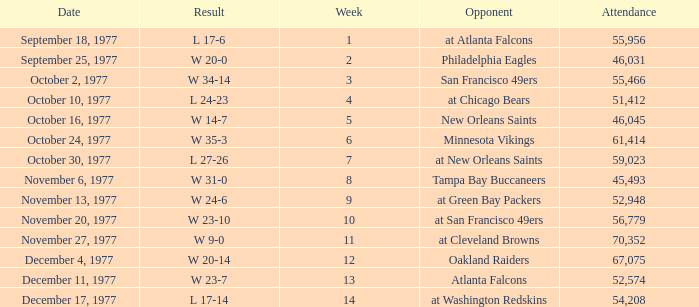What is the lowest attendance for week 2? 46031.0. 